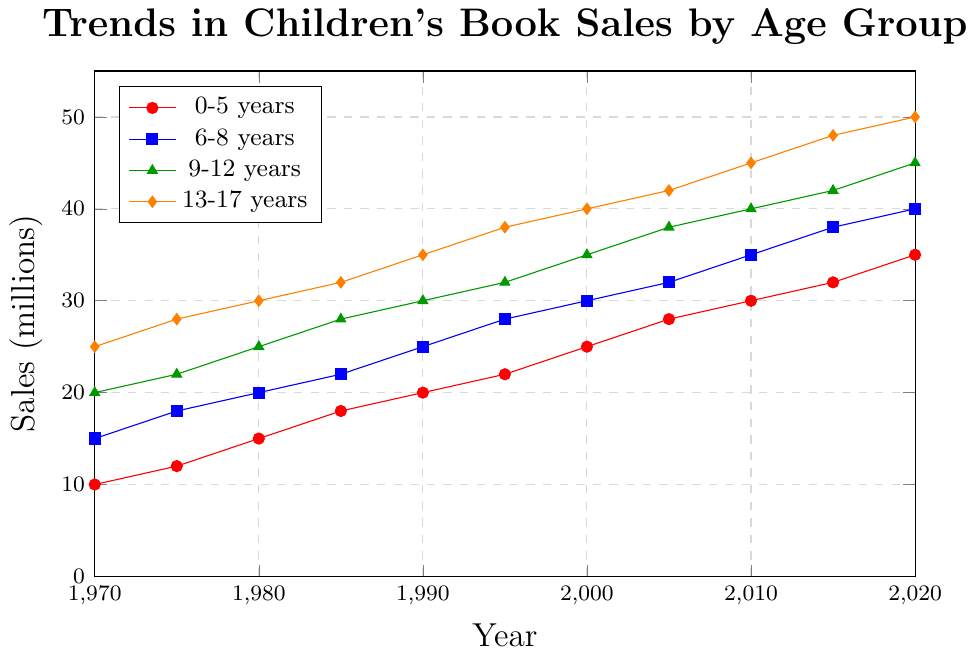What's the trend of book sales for the 0-5 years age group from 1970 to 2020? The book sales in the 0-5 years age group show a general upward trend. Sales started at 10 million in 1970 and increased gradually to 35 million by 2020.
Answer: Upward trend Which age group had the highest book sales in 1990? In 1990, the 13-17 years age group had the highest book sales, with 35 million.
Answer: 13-17 years How many times did the book sales for the 9-12 years age group increase from 1970 to 2020? In 1970, sales for the 9-12 years age group were 20 million, and in 2020, they were 45 million. The increase can be calculated as 45 / 20 = 2.25, meaning sales increased by 2.25 times.
Answer: 2.25 times Which age group experienced the sharpest increase in book sales over the given period? To determine this, calculate the increases for each group from 1970 to 2020: 
- 0-5 years: from 10 to 35 (increase of 25)
- 6-8 years: from 15 to 40 (increase of 25)
- 9-12 years: from 20 to 45 (increase of 25)
- 13-17 years: from 25 to 50 (increase of 25)
All age groups experienced the same numeric increase of 25 million.
Answer: All age groups equally By how much did the book sales for the 13-17 years age group exceed those of the 0-5 years age group in 2020? In 2020, the book sales for the 13-17 years age group were 50 million, and for the 0-5 years age group, it was 35 million. The difference is 50 - 35 = 15 million.
Answer: 15 million In which decade did the 0-5 years age group see the highest percentage growth in sales? Calculate the percentage growth for each decade for the 0-5 years age group:
- 1970 to 1980: ((15 - 10) / 10) * 100 = 50%
- 1980 to 1990: ((20 - 15) / 15) * 100 = 33.33%
- 1990 to 2000: ((25 - 20) / 20) * 100 = 25%
- 2000 to 2010: ((30 - 25) / 25) * 100 = 20%
- 2010 to 2020: ((35 - 30) / 30) * 100 = 16.67%
The highest percentage growth occurred from 1970 to 1980 with a 50% increase.
Answer: 1970 to 1980 Which age group's book sales grew steadily without any dips over the 50 years? Observing the trends, all age groups experienced steady growth without any dips: 0-5 years, 6-8 years, 9-12 years, and 13-17 years.
Answer: All age groups In 1985, which age group had book sales closest to 25 million? In 1985, the 9-12 years age group had sales of 28 million, which is the closest to 25 million among all groups.
Answer: 9-12 years 